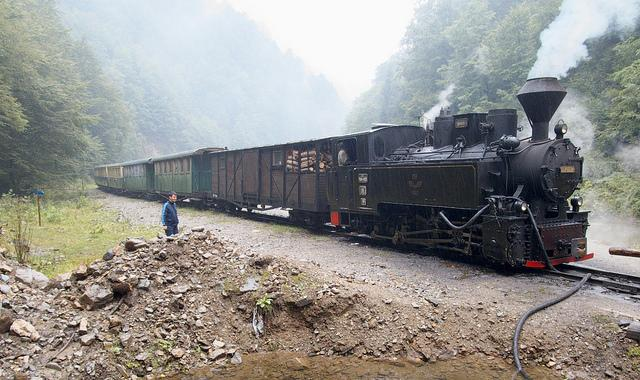What is being used to maintain the steam engine's momentum?

Choices:
A) wood
B) coal
C) steel
D) electricity wood 